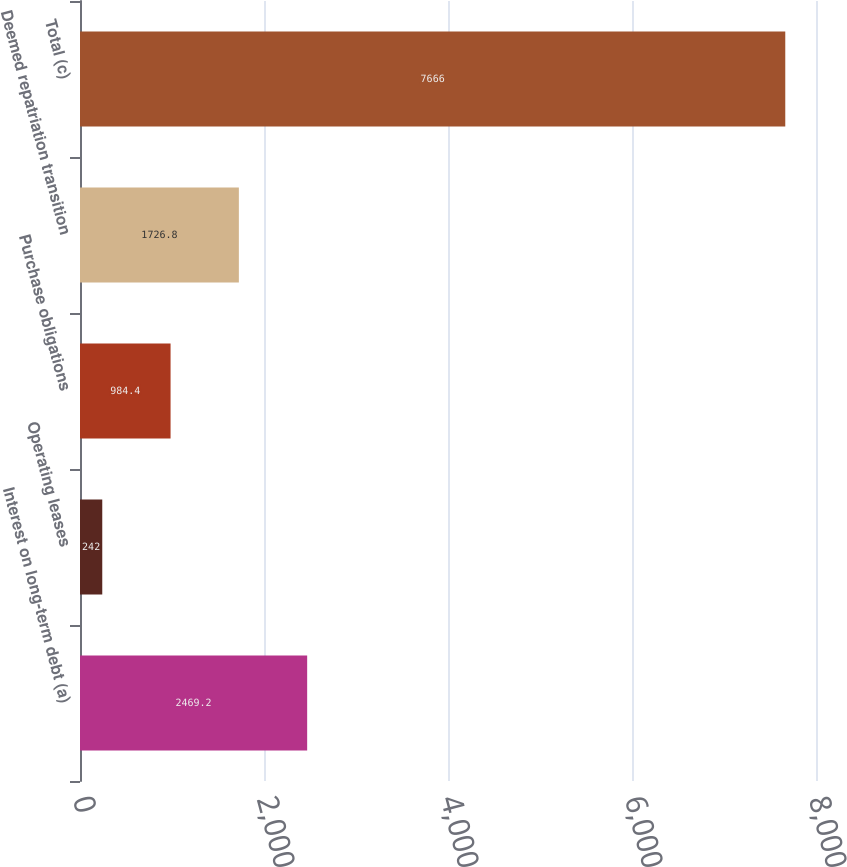<chart> <loc_0><loc_0><loc_500><loc_500><bar_chart><fcel>Interest on long-term debt (a)<fcel>Operating leases<fcel>Purchase obligations<fcel>Deemed repatriation transition<fcel>Total (c)<nl><fcel>2469.2<fcel>242<fcel>984.4<fcel>1726.8<fcel>7666<nl></chart> 